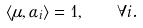<formula> <loc_0><loc_0><loc_500><loc_500>\langle \mu , \alpha _ { i } \rangle = 1 , \quad \forall i .</formula> 